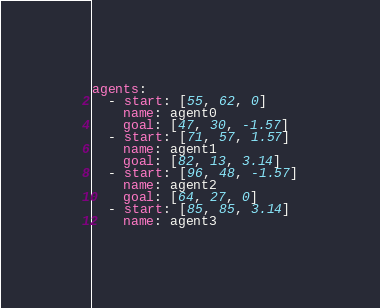Convert code to text. <code><loc_0><loc_0><loc_500><loc_500><_YAML_>agents:
  - start: [55, 62, 0]
    name: agent0
    goal: [47, 30, -1.57]
  - start: [71, 57, 1.57]
    name: agent1
    goal: [82, 13, 3.14]
  - start: [96, 48, -1.57]
    name: agent2
    goal: [64, 27, 0]
  - start: [85, 85, 3.14]
    name: agent3</code> 